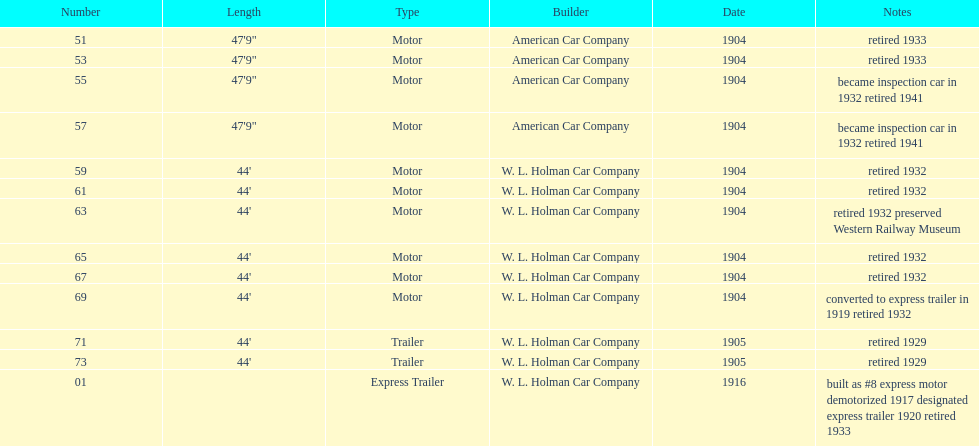How long did it take number 71 to retire? 24. Would you be able to parse every entry in this table? {'header': ['Number', 'Length', 'Type', 'Builder', 'Date', 'Notes'], 'rows': [['51', '47\'9"', 'Motor', 'American Car Company', '1904', 'retired 1933'], ['53', '47\'9"', 'Motor', 'American Car Company', '1904', 'retired 1933'], ['55', '47\'9"', 'Motor', 'American Car Company', '1904', 'became inspection car in 1932 retired 1941'], ['57', '47\'9"', 'Motor', 'American Car Company', '1904', 'became inspection car in 1932 retired 1941'], ['59', "44'", 'Motor', 'W. L. Holman Car Company', '1904', 'retired 1932'], ['61', "44'", 'Motor', 'W. L. Holman Car Company', '1904', 'retired 1932'], ['63', "44'", 'Motor', 'W. L. Holman Car Company', '1904', 'retired 1932 preserved Western Railway Museum'], ['65', "44'", 'Motor', 'W. L. Holman Car Company', '1904', 'retired 1932'], ['67', "44'", 'Motor', 'W. L. Holman Car Company', '1904', 'retired 1932'], ['69', "44'", 'Motor', 'W. L. Holman Car Company', '1904', 'converted to express trailer in 1919 retired 1932'], ['71', "44'", 'Trailer', 'W. L. Holman Car Company', '1905', 'retired 1929'], ['73', "44'", 'Trailer', 'W. L. Holman Car Company', '1905', 'retired 1929'], ['01', '', 'Express Trailer', 'W. L. Holman Car Company', '1916', 'built as #8 express motor demotorized 1917 designated express trailer 1920 retired 1933']]} 